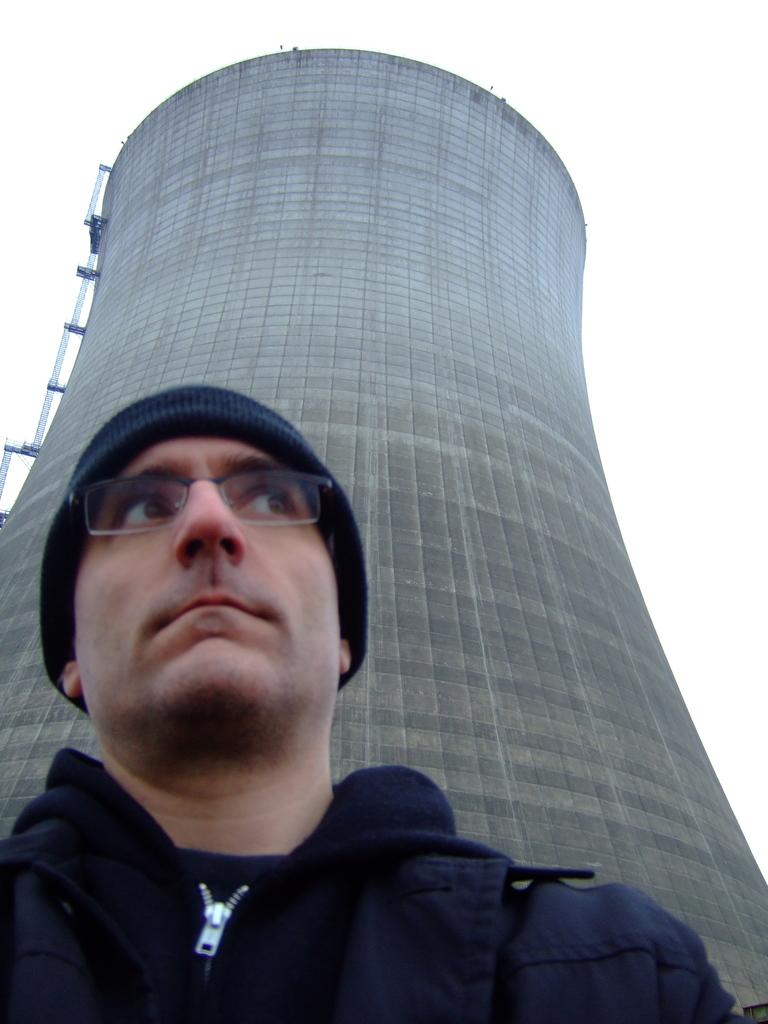Who is present in the image? There is a man in the image. What is the man wearing on his head? The man is wearing a cap. What type of eyewear is the man wearing? The man is wearing spectacles. What can be seen in the background of the image? There is a building in the background of the image. What type of swimwear is the man wearing in the image? The man is not wearing swimwear in the image; he is wearing a cap and spectacles. Where is the church located in the image? There is no church present in the image; it features a man wearing a cap and spectacles with a building in the background. 